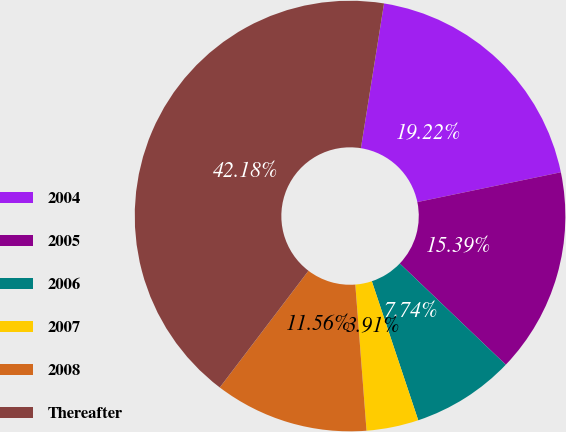<chart> <loc_0><loc_0><loc_500><loc_500><pie_chart><fcel>2004<fcel>2005<fcel>2006<fcel>2007<fcel>2008<fcel>Thereafter<nl><fcel>19.22%<fcel>15.39%<fcel>7.74%<fcel>3.91%<fcel>11.56%<fcel>42.18%<nl></chart> 